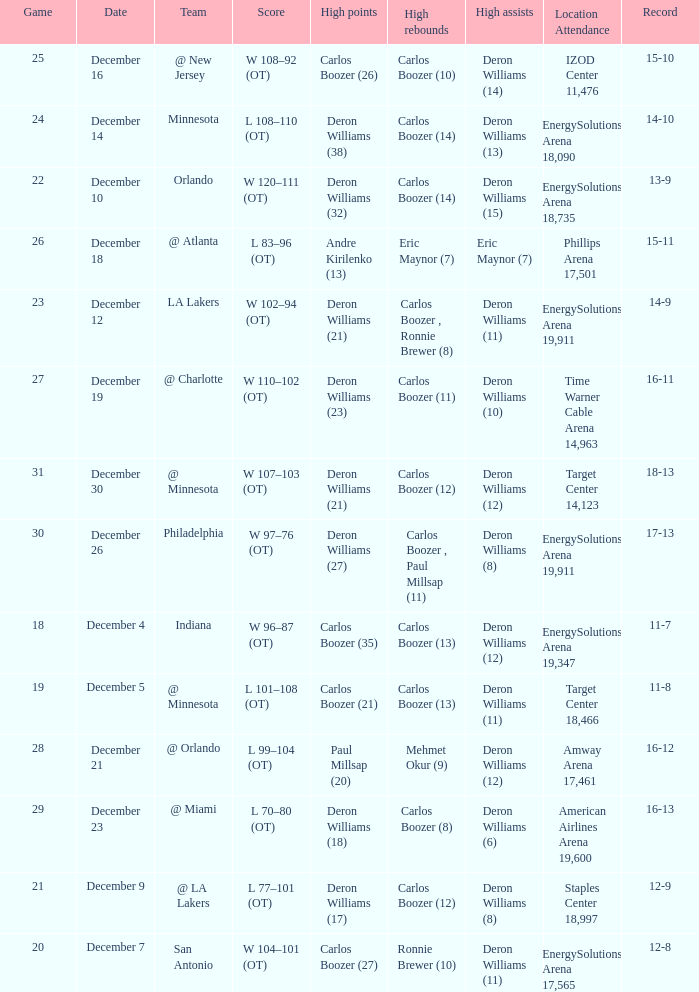How many different high rebound results are there for the game number 26? 1.0. 